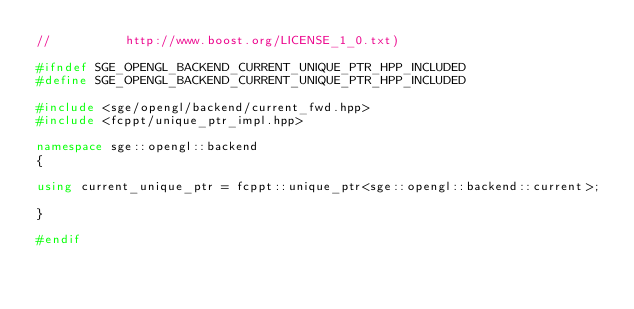Convert code to text. <code><loc_0><loc_0><loc_500><loc_500><_C++_>//          http://www.boost.org/LICENSE_1_0.txt)

#ifndef SGE_OPENGL_BACKEND_CURRENT_UNIQUE_PTR_HPP_INCLUDED
#define SGE_OPENGL_BACKEND_CURRENT_UNIQUE_PTR_HPP_INCLUDED

#include <sge/opengl/backend/current_fwd.hpp>
#include <fcppt/unique_ptr_impl.hpp>

namespace sge::opengl::backend
{

using current_unique_ptr = fcppt::unique_ptr<sge::opengl::backend::current>;

}

#endif
</code> 